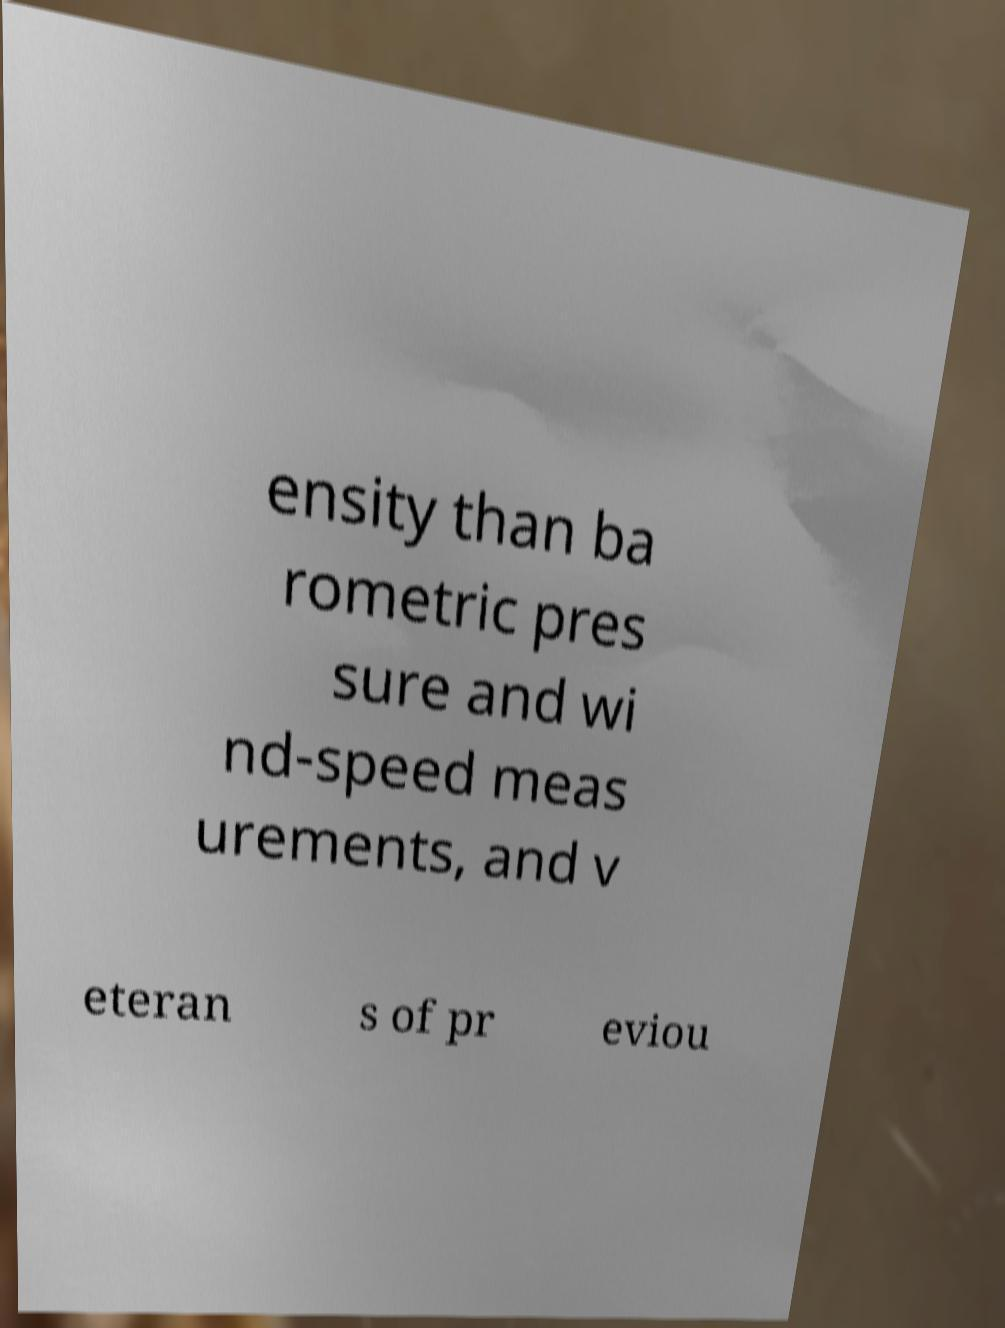For documentation purposes, I need the text within this image transcribed. Could you provide that? ensity than ba rometric pres sure and wi nd-speed meas urements, and v eteran s of pr eviou 